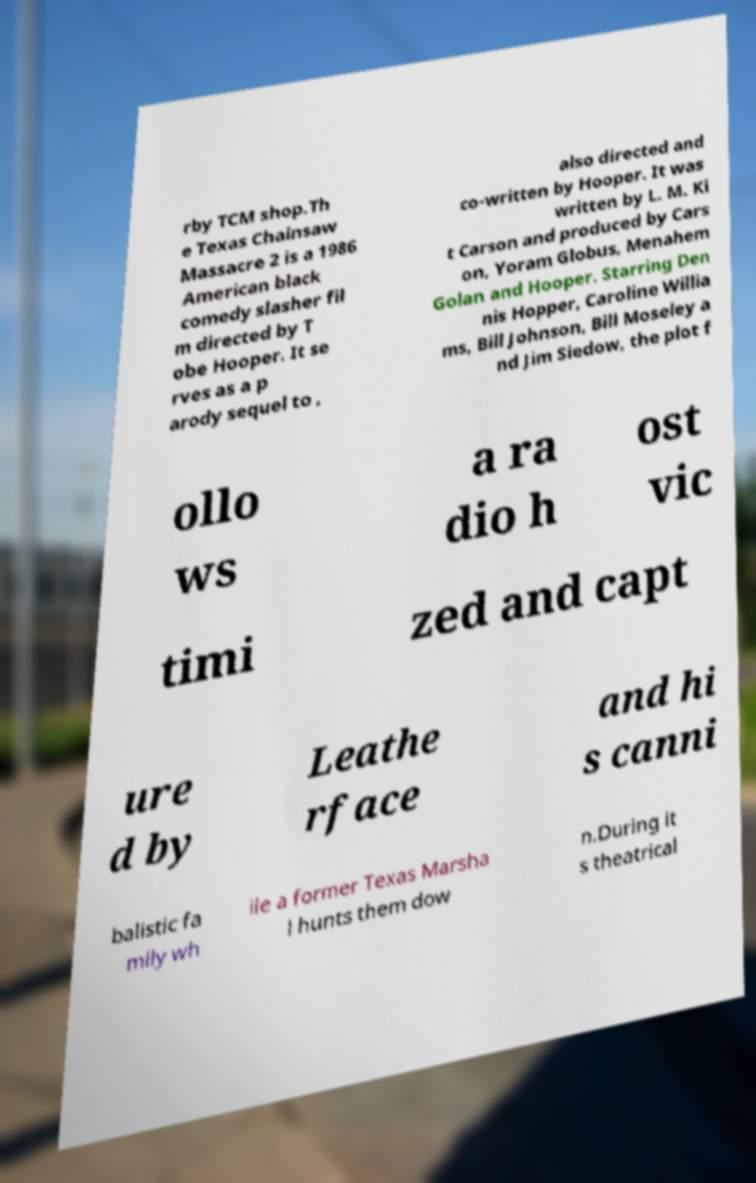Can you accurately transcribe the text from the provided image for me? rby TCM shop.Th e Texas Chainsaw Massacre 2 is a 1986 American black comedy slasher fil m directed by T obe Hooper. It se rves as a p arody sequel to , also directed and co-written by Hooper. It was written by L. M. Ki t Carson and produced by Cars on, Yoram Globus, Menahem Golan and Hooper. Starring Den nis Hopper, Caroline Willia ms, Bill Johnson, Bill Moseley a nd Jim Siedow, the plot f ollo ws a ra dio h ost vic timi zed and capt ure d by Leathe rface and hi s canni balistic fa mily wh ile a former Texas Marsha l hunts them dow n.During it s theatrical 